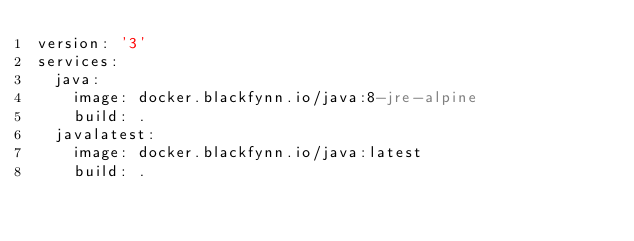Convert code to text. <code><loc_0><loc_0><loc_500><loc_500><_YAML_>version: '3'
services:
  java:
    image: docker.blackfynn.io/java:8-jre-alpine
    build: .
  javalatest:
    image: docker.blackfynn.io/java:latest
    build: .
</code> 